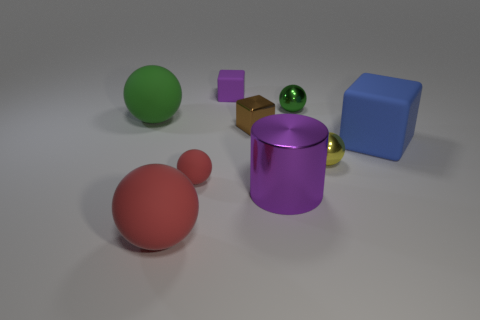Subtract 1 balls. How many balls are left? 4 Subtract all big green rubber balls. How many balls are left? 4 Subtract all yellow balls. How many balls are left? 4 Subtract all gray balls. Subtract all gray cylinders. How many balls are left? 5 Add 1 small rubber cubes. How many objects exist? 10 Subtract all cubes. How many objects are left? 6 Subtract 0 purple balls. How many objects are left? 9 Subtract all brown shiny cubes. Subtract all red objects. How many objects are left? 6 Add 7 green things. How many green things are left? 9 Add 2 large things. How many large things exist? 6 